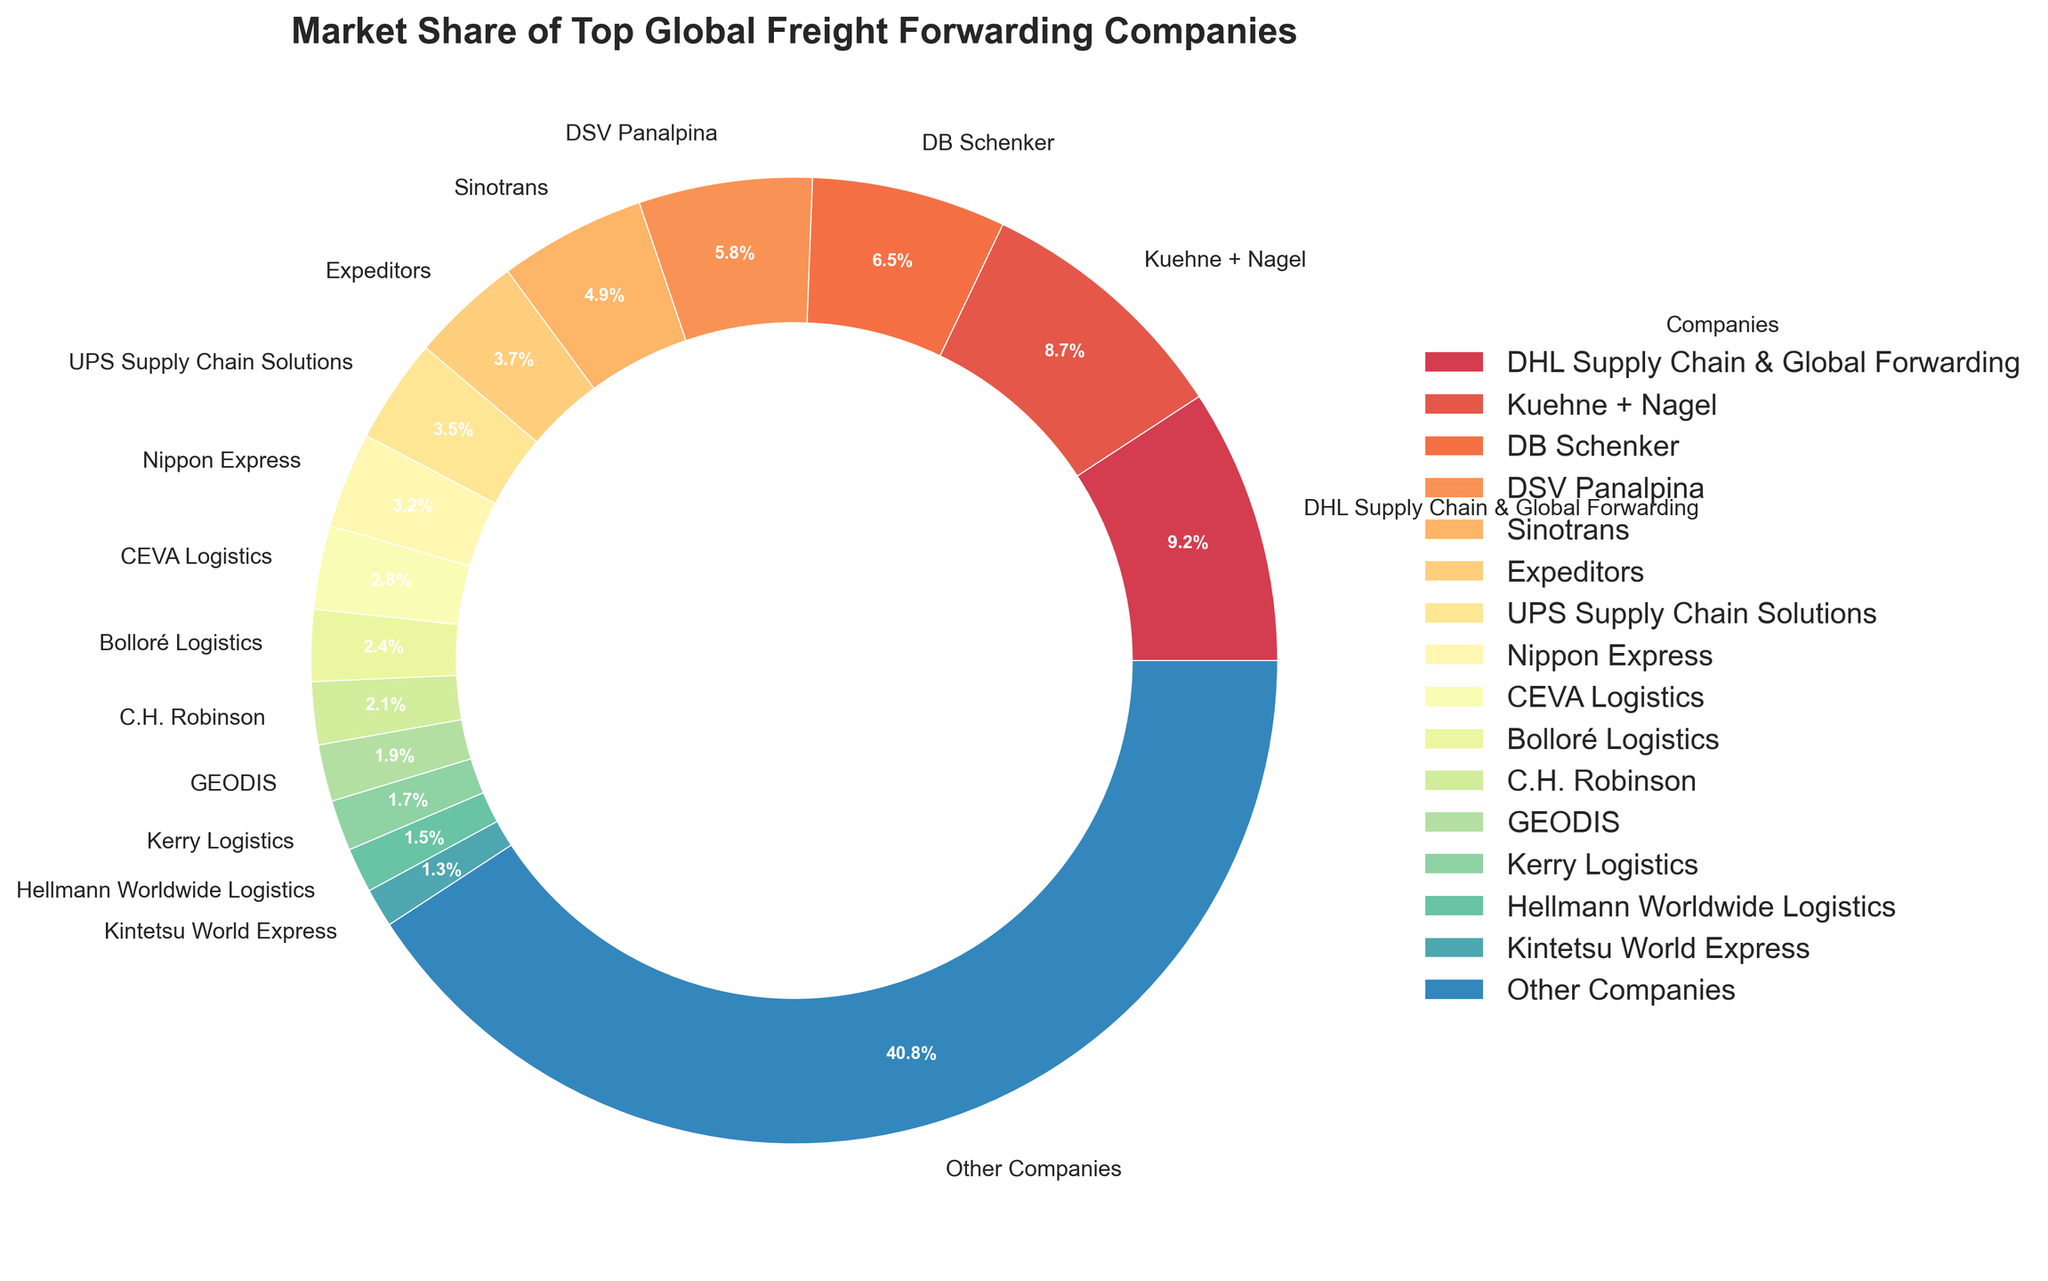what is the market share of DHL Supply Chain & Global Forwarding? DHL Supply Chain & Global Forwarding is represented with a label and a pie section indicating its market share. According to the figure, the company holds a market share of 9.2%
Answer: 9.2% How does the market share of Kuehne + Nagel compare to DB Schenker? Kuehne + Nagel's market share is identified as 8.7%, whereas DB Schenker's share is indicated as 6.5%. The comparison shows that Kuehne + Nagel has a higher market share than DB Schenker
Answer: Kuehne + Nagel has a higher market share What is the combined market share of DSV Panalpina and Sinotrans? DSV Panalpina has a market share of 5.8% and Sinotrans holds 4.9%. Adding these shares together gives 5.8% + 4.9% = 10.7%
Answer: 10.7% Is the market share of Expeditors greater than 3%? According to the figure, Expeditors has a market share of 3.7%, which is greater than 3%
Answer: Yes Comparing the market shares, is Nippon Express above or below 4%? Nippon Express is shown to have a market share of 3.2%, which is below 4%
Answer: Below 4% How much larger is the market share of Other Companies compared to DB Schenker? Other Companies have a market share of 40.8%, while DB Schenker has 6.5%. The difference is calculated as 40.8% - 6.5% = 34.3%
Answer: 34.3% What is the total market share of the top three companies? The top three companies are DHL Supply Chain & Global Forwarding (9.2%), Kuehne + Nagel (8.7%), and DB Schenker (6.5%). The total is calculated by adding these shares together: 9.2% + 8.7% + 6.5% = 24.4%
Answer: 24.4% Compare the market share of C.H. Robinson to GEODIS. C.H. Robinson holds a 2.1% market share, whereas GEODIS has 1.9%. C.H. Robinson's share is higher than that of GEODIS
Answer: C.H. Robinson has a higher market share Which companies have a market share less than 2%? Inspecting the figure, GEODIS (1.9%), Kerry Logistics (1.7%), Hellmann Worldwide Logistics (1.5%), and Kintetsu World Express (1.3%) all have market shares below 2%
Answer: GEODIS, Kerry Logistics, Hellmann Worldwide Logistics, Kintetsu World Express What is the percentage difference between the market shares of UPS Supply Chain Solutions and CEVA Logistics? UPS Supply Chain Solutions has a market share of 3.5%, whereas CEVA Logistics has 2.8%. The percentage difference is calculated as 3.5% - 2.8% = 0.7%
Answer: 0.7% 